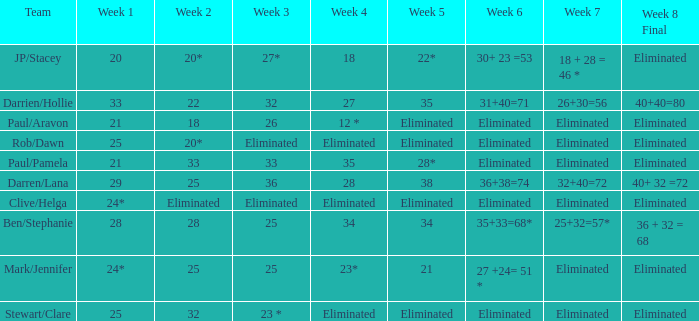Name the team for week 1 of 33 Darrien/Hollie. 